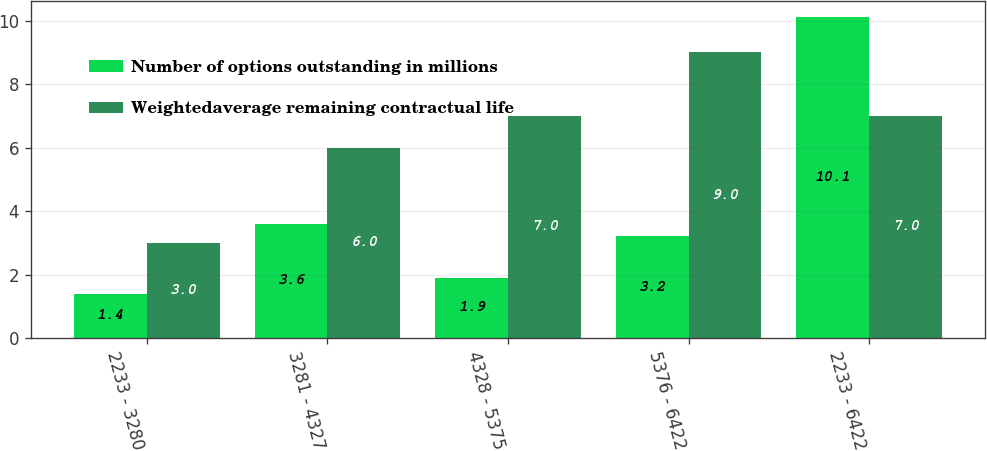Convert chart to OTSL. <chart><loc_0><loc_0><loc_500><loc_500><stacked_bar_chart><ecel><fcel>2233 - 3280<fcel>3281 - 4327<fcel>4328 - 5375<fcel>5376 - 6422<fcel>2233 - 6422<nl><fcel>Number of options outstanding in millions<fcel>1.4<fcel>3.6<fcel>1.9<fcel>3.2<fcel>10.1<nl><fcel>Weightedaverage remaining contractual life<fcel>3<fcel>6<fcel>7<fcel>9<fcel>7<nl></chart> 